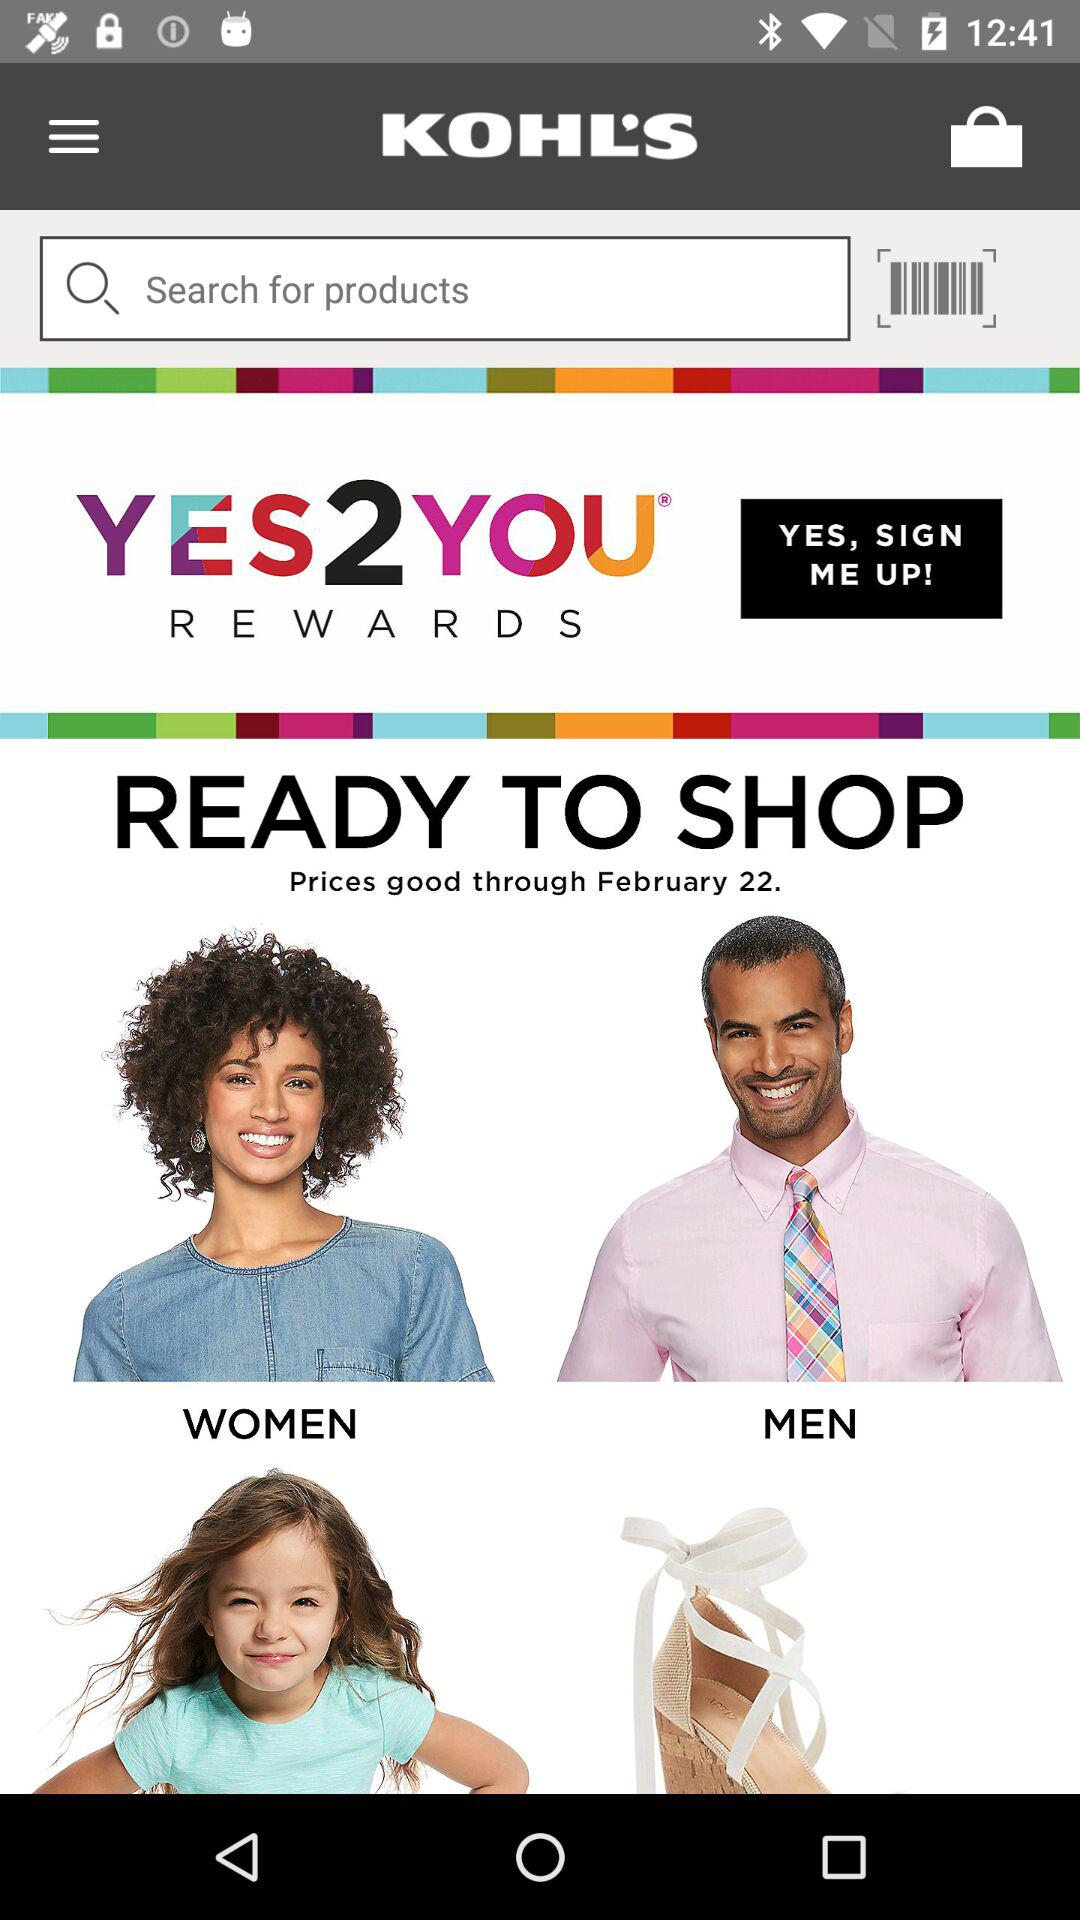What is the application name? The application name is "KOHL'S". 